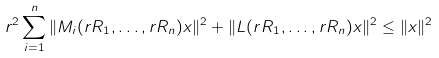Convert formula to latex. <formula><loc_0><loc_0><loc_500><loc_500>r ^ { 2 } \sum _ { i = 1 } ^ { n } \| M _ { i } ( r R _ { 1 } , \dots , r R _ { n } ) x \| ^ { 2 } + \| L ( r R _ { 1 } , \dots , r R _ { n } ) x \| ^ { 2 } \leq \| x \| ^ { 2 }</formula> 